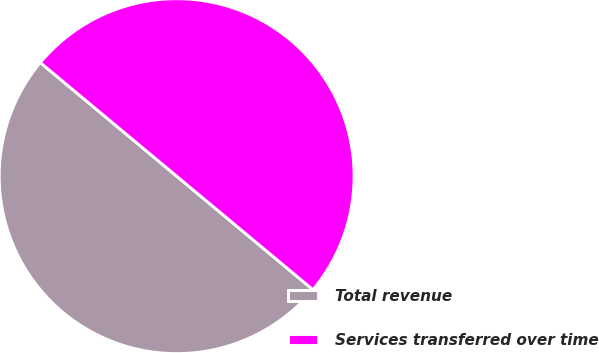Convert chart. <chart><loc_0><loc_0><loc_500><loc_500><pie_chart><fcel>Total revenue<fcel>Services transferred over time<nl><fcel>50.0%<fcel>50.0%<nl></chart> 